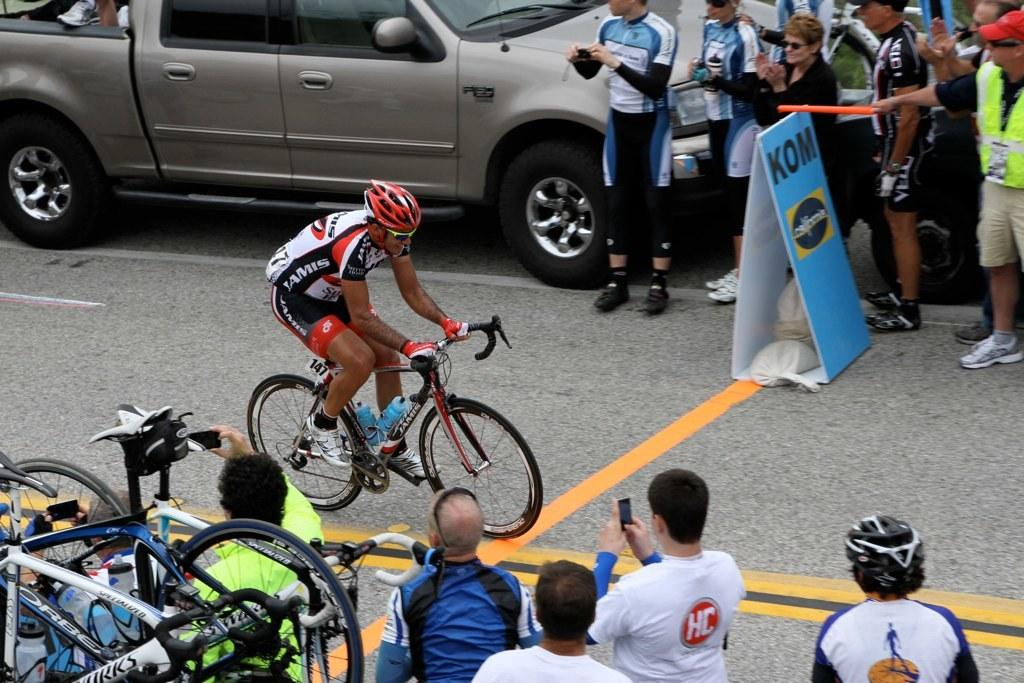What is the man in the image doing? The man is riding a bicycle in the image. Where is the man riding the bicycle? The man is in a street. What can be seen in the background of the image? In the background of the image, there is a car, a hoarding, a group of persons, a mobile, a group of bicycles, and bottles. How many giants are present in the image? There are no giants present in the image. 